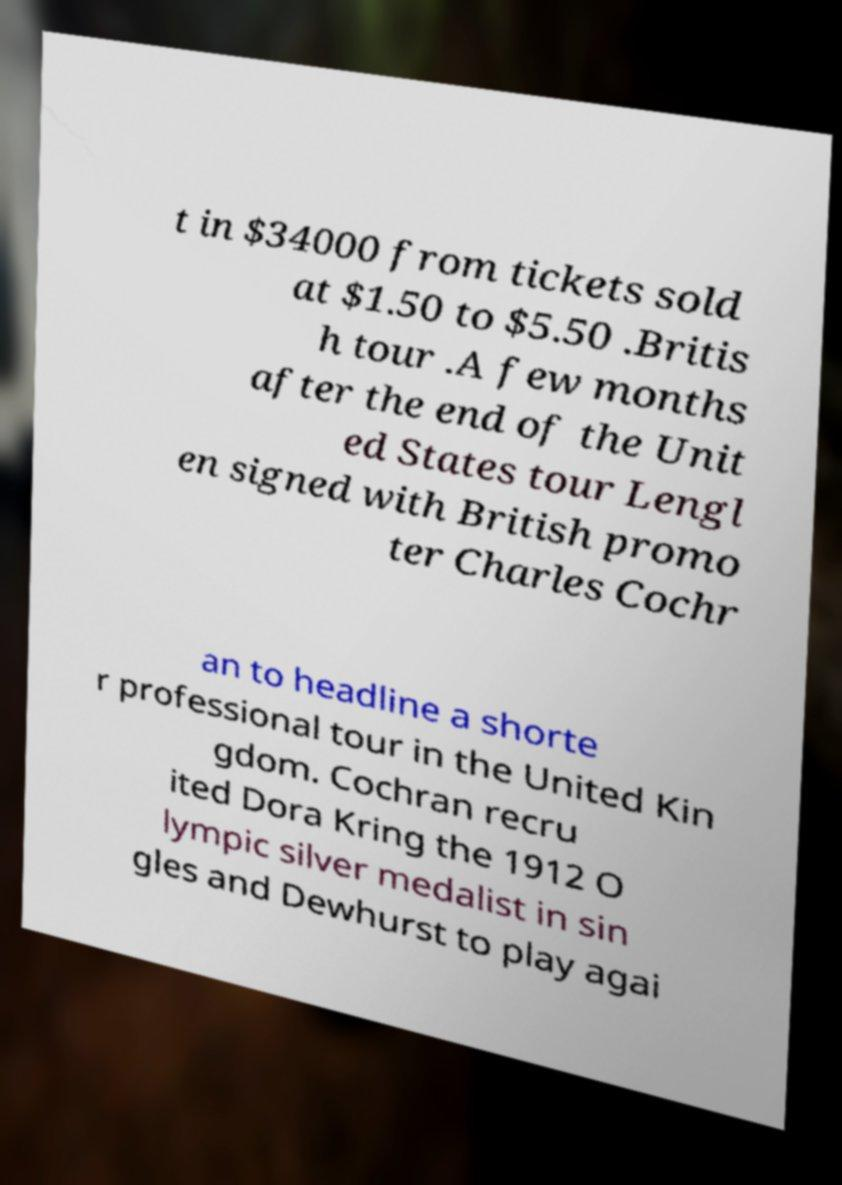Please identify and transcribe the text found in this image. t in $34000 from tickets sold at $1.50 to $5.50 .Britis h tour .A few months after the end of the Unit ed States tour Lengl en signed with British promo ter Charles Cochr an to headline a shorte r professional tour in the United Kin gdom. Cochran recru ited Dora Kring the 1912 O lympic silver medalist in sin gles and Dewhurst to play agai 